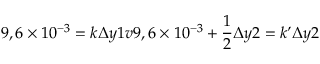Convert formula to latex. <formula><loc_0><loc_0><loc_500><loc_500>9 , 6 \times 1 0 ^ { - 3 } = k \Delta y 1 v 9 , 6 \times 1 0 ^ { - 3 } + \frac { 1 } { 2 } \Delta y 2 = k \Delta y 2</formula> 